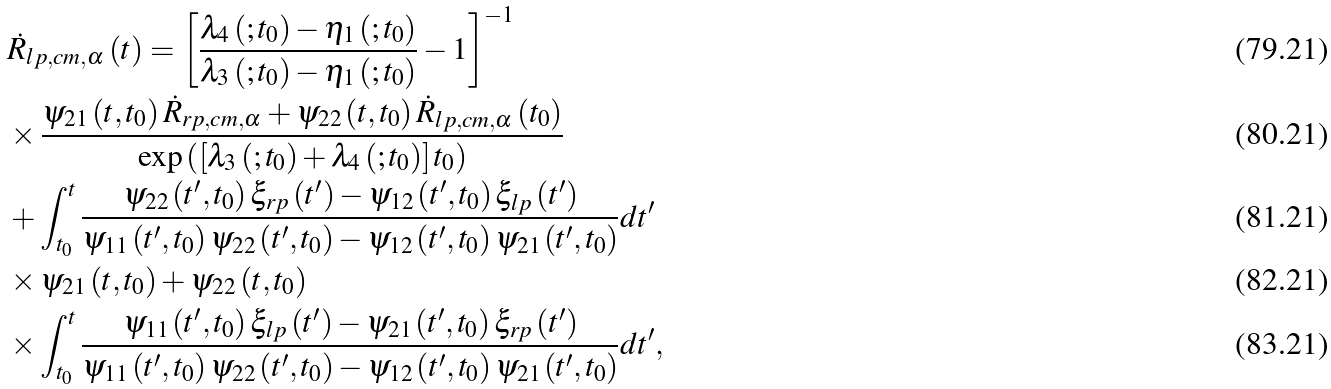Convert formula to latex. <formula><loc_0><loc_0><loc_500><loc_500>& \dot { R } _ { l p , c m , \alpha } \left ( t \right ) = \left [ \frac { \lambda _ { 4 } \left ( ; t _ { 0 } \right ) - \eta _ { 1 } \left ( ; t _ { 0 } \right ) } { \lambda _ { 3 } \left ( ; t _ { 0 } \right ) - \eta _ { 1 } \left ( ; t _ { 0 } \right ) } - 1 \right ] ^ { - 1 } \\ & \times \frac { \psi _ { 2 1 } \left ( t , t _ { 0 } \right ) \dot { R } _ { r p , c m , \alpha } + \psi _ { 2 2 } \left ( t , t _ { 0 } \right ) \dot { R } _ { l p , c m , \alpha } \left ( t _ { 0 } \right ) } { \exp \left ( \left [ \lambda _ { 3 } \left ( ; t _ { 0 } \right ) + \lambda _ { 4 } \left ( ; t _ { 0 } \right ) \right ] t _ { 0 } \right ) } \\ & + \int _ { t _ { 0 } } ^ { t } \frac { \psi _ { 2 2 } \left ( t ^ { \prime } , t _ { 0 } \right ) \xi _ { r p } \left ( t ^ { \prime } \right ) - \psi _ { 1 2 } \left ( t ^ { \prime } , t _ { 0 } \right ) \xi _ { l p } \left ( t ^ { \prime } \right ) } { \psi _ { 1 1 } \left ( t ^ { \prime } , t _ { 0 } \right ) \psi _ { 2 2 } \left ( t ^ { \prime } , t _ { 0 } \right ) - \psi _ { 1 2 } \left ( t ^ { \prime } , t _ { 0 } \right ) \psi _ { 2 1 } \left ( t ^ { \prime } , t _ { 0 } \right ) } d t ^ { \prime } \\ & \times \psi _ { 2 1 } \left ( t , t _ { 0 } \right ) + \psi _ { 2 2 } \left ( t , t _ { 0 } \right ) \\ & \times \int _ { t _ { 0 } } ^ { t } \frac { \psi _ { 1 1 } \left ( t ^ { \prime } , t _ { 0 } \right ) \xi _ { l p } \left ( t ^ { \prime } \right ) - \psi _ { 2 1 } \left ( t ^ { \prime } , t _ { 0 } \right ) \xi _ { r p } \left ( t ^ { \prime } \right ) } { \psi _ { 1 1 } \left ( t ^ { \prime } , t _ { 0 } \right ) \psi _ { 2 2 } \left ( t ^ { \prime } , t _ { 0 } \right ) - \psi _ { 1 2 } \left ( t ^ { \prime } , t _ { 0 } \right ) \psi _ { 2 1 } \left ( t ^ { \prime } , t _ { 0 } \right ) } d t ^ { \prime } ,</formula> 